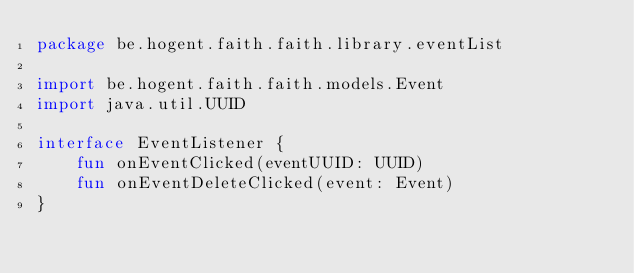<code> <loc_0><loc_0><loc_500><loc_500><_Kotlin_>package be.hogent.faith.faith.library.eventList

import be.hogent.faith.faith.models.Event
import java.util.UUID

interface EventListener {
    fun onEventClicked(eventUUID: UUID)
    fun onEventDeleteClicked(event: Event)
}
</code> 